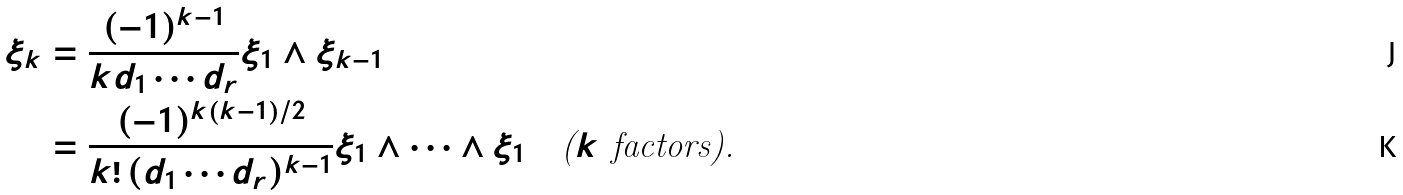Convert formula to latex. <formula><loc_0><loc_0><loc_500><loc_500>\xi _ { k } & = \frac { ( - 1 ) ^ { k - 1 } } { k d _ { 1 } \cdots d _ { r } } \xi _ { 1 } \wedge \xi _ { k - 1 } \\ & = \frac { ( - 1 ) ^ { k ( k - 1 ) / 2 } } { k ! \, ( d _ { 1 } \cdots d _ { r } ) ^ { k - 1 } } \xi _ { 1 } \wedge \cdots \wedge \xi _ { 1 } \quad \text {($k$ factors).}</formula> 